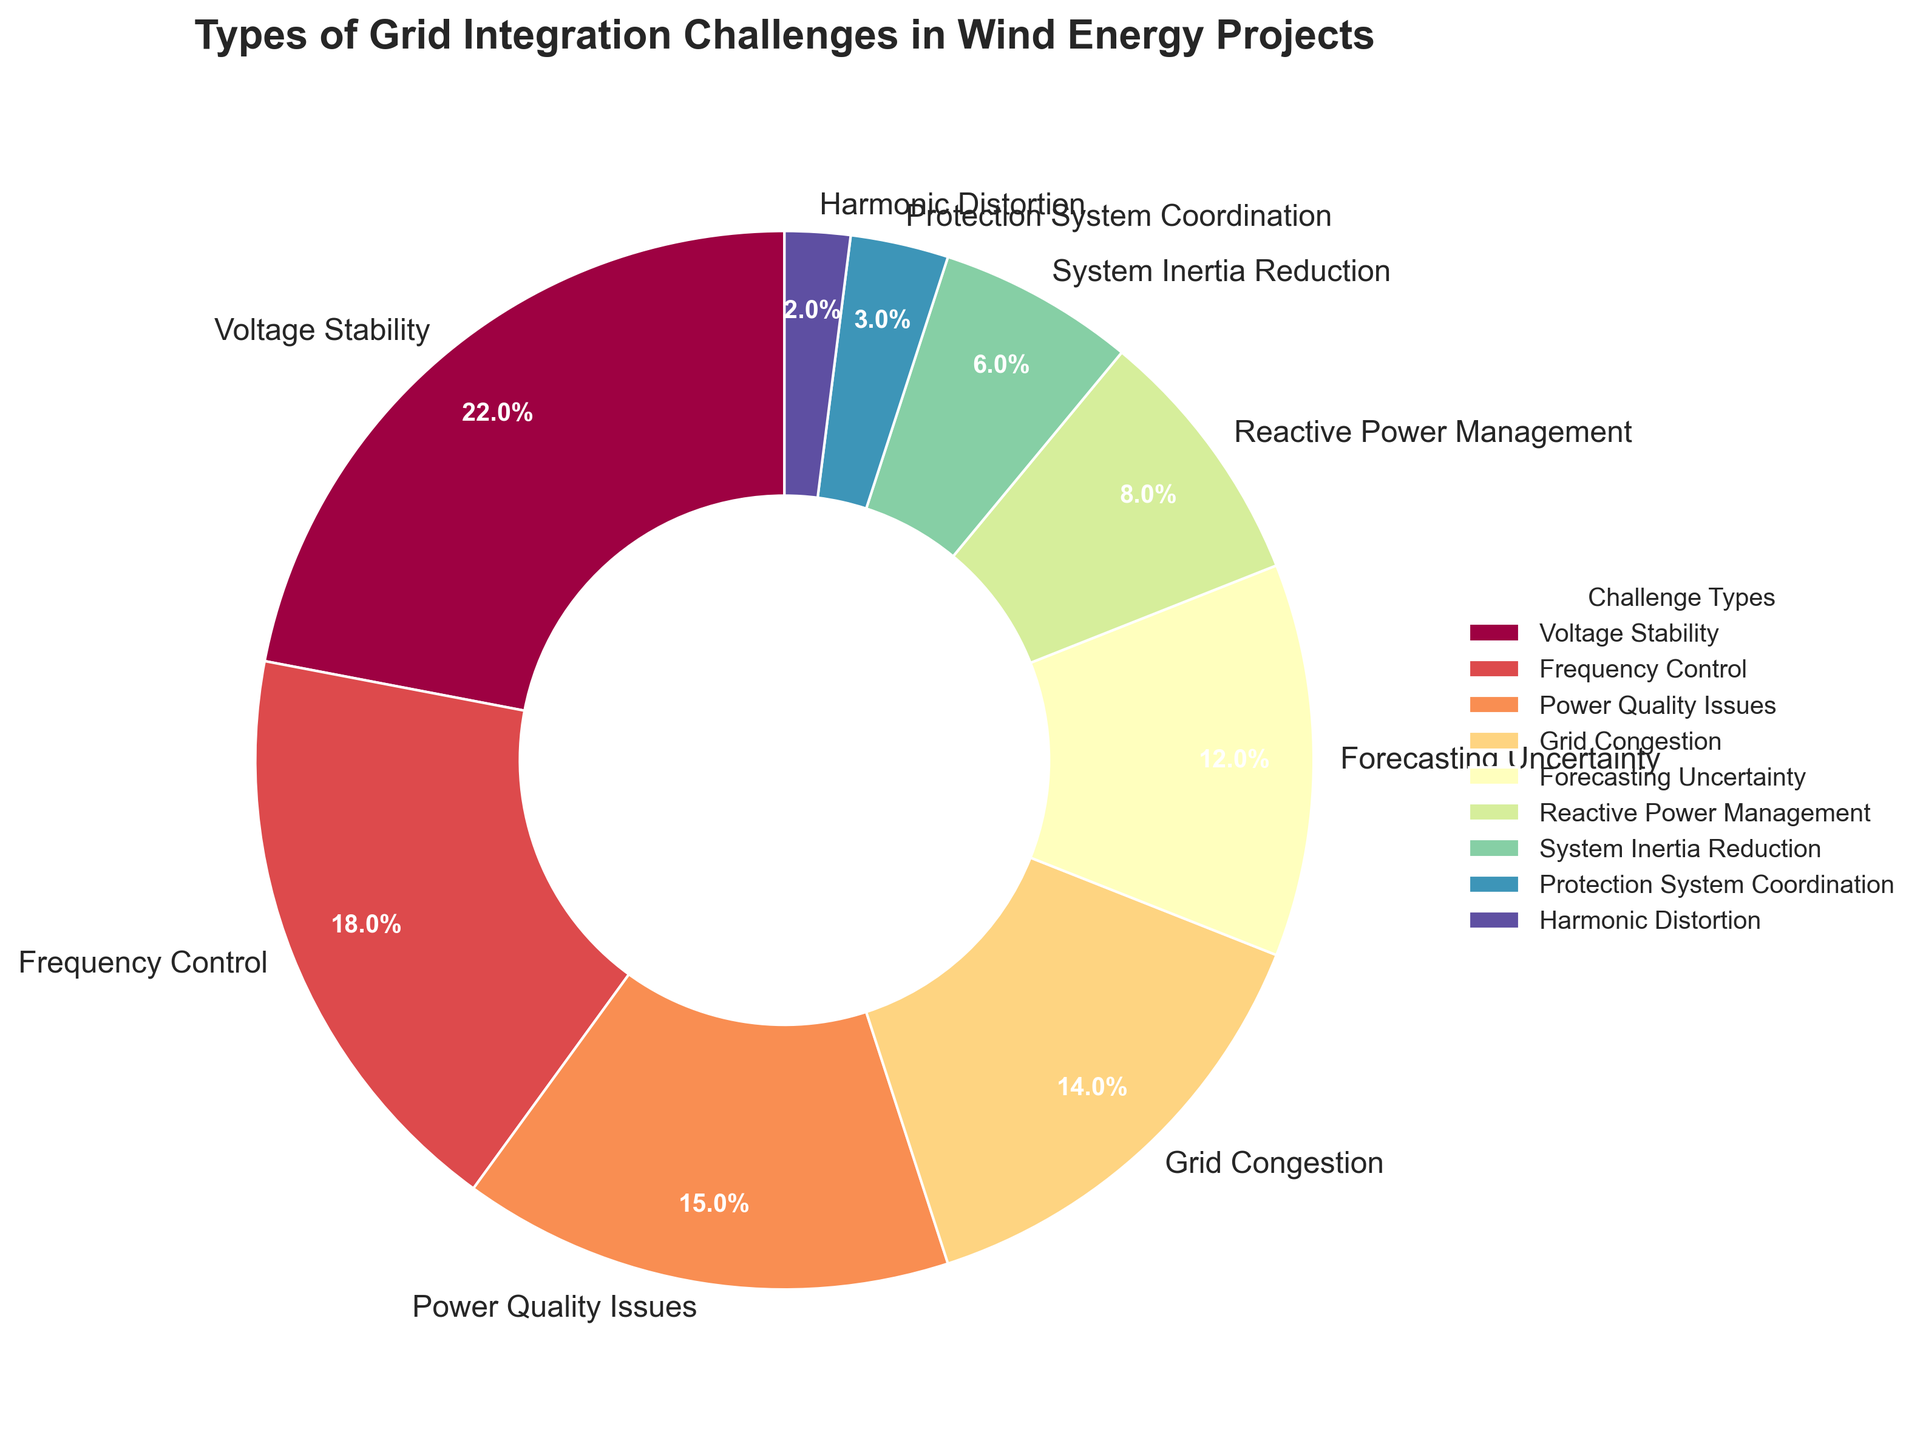What challenge type has the highest percentage in grid integration for wind energy projects? The chart shows various percentages for different challenge types. The segment with the largest percentage corresponds to "Voltage Stability."
Answer: Voltage Stability What is the combined percentage of Frequency Control, Reactive Power Management, and Harmonic Distortion challenges? Sum the percentages for Frequency Control (18%), Reactive Power Management (8%), and Harmonic Distortion (2%). The combined percentage is 18 + 8 + 2 = 28%.
Answer: 28% Which challenge has a higher percentage: Grid Congestion or Power Quality Issues? Compare the percentage of Grid Congestion (14%) with that of Power Quality Issues (15%). Power Quality Issues have a higher percentage.
Answer: Power Quality Issues How much more percentage does Voltage Stability have compared to System Inertia Reduction? Calculate the difference between Voltage Stability (22%) and System Inertia Reduction (6%). The difference is 22 - 6 = 16%.
Answer: 16% What percentage of the challenges are related to protection and distortion (Protection System Coordination and Harmonic Distortion combined)? Sum the percentages for Protection System Coordination (3%) and Harmonic Distortion (2%). The combined percentage is 3 + 2 = 5%.
Answer: 5% Is the percentage for Forecasting Uncertainty greater than for Reactive Power Management? Compare the percentage of Forecasting Uncertainty (12%) with that of Reactive Power Management (8%). Forecasting Uncertainty has a greater percentage.
Answer: Yes Rank the top three challenges based on their percentages. Review the percentages for all challenge types and identify the top three. They are: Voltage Stability (22%), Frequency Control (18%), and Power Quality Issues (15%).
Answer: Voltage Stability, Frequency Control, Power Quality Issues What is the difference in percentage between the smallest and largest challenge types? Identify the largest percentage (Voltage Stability at 22%) and the smallest percentage (Harmonic Distortion at 2%). The difference is 22 - 2 = 20%.
Answer: 20% If the total percentage is 100%, what is the percentage for challenges not including Voltage Stability and Frequency Control? Subtract the percentages for Voltage Stability (22%) and Frequency Control (18%) from 100%. The combined percentage for these two is 22 + 18 = 40%. Therefore, the percentage for the other challenges is 100 - 40 = 60%.
Answer: 60% What colors represent Frequency Control and System Inertia Reduction on the pie chart? Visual inspection of the pie chart shows that Frequency Control and System Inertia Reduction are represented by different colors. Frequency Control is shown in a color like blue, and System Inertia Reduction is in a color like green.
Answer: Blue (Frequency Control), Green (System Inertia Reduction) 